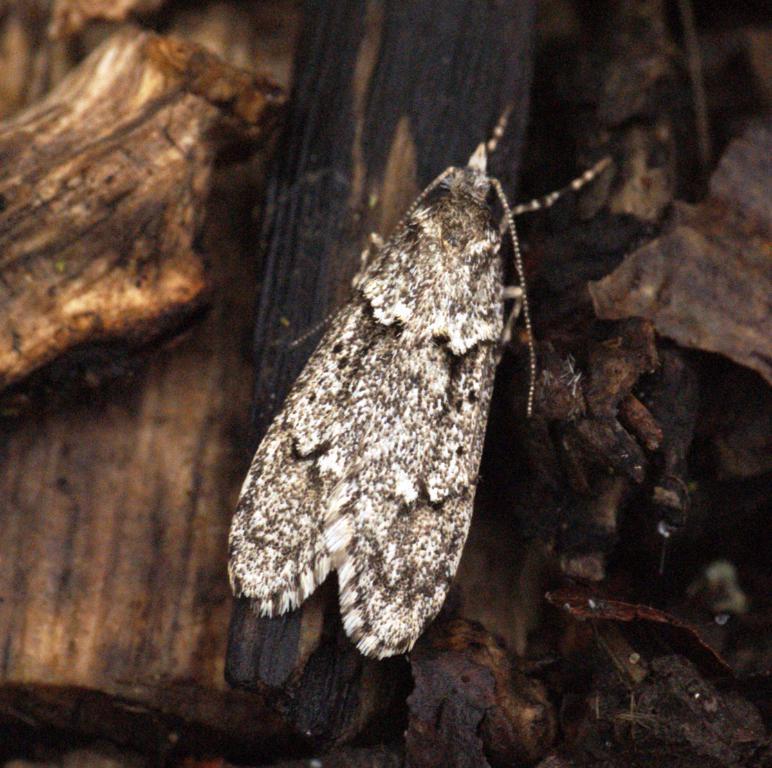Could you give a brief overview of what you see in this image? In this image, we can see a moth on the wooden stick. Background we can see a wooden pieces. 